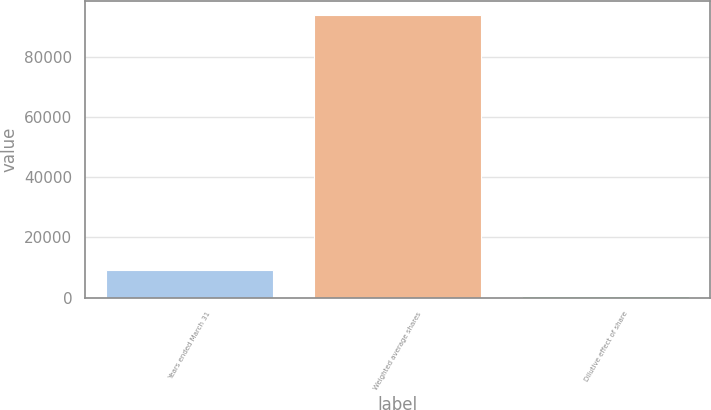<chart> <loc_0><loc_0><loc_500><loc_500><bar_chart><fcel>Years ended March 31<fcel>Weighted average shares<fcel>Dilutive effect of share<nl><fcel>9168.3<fcel>94020.3<fcel>621<nl></chart> 